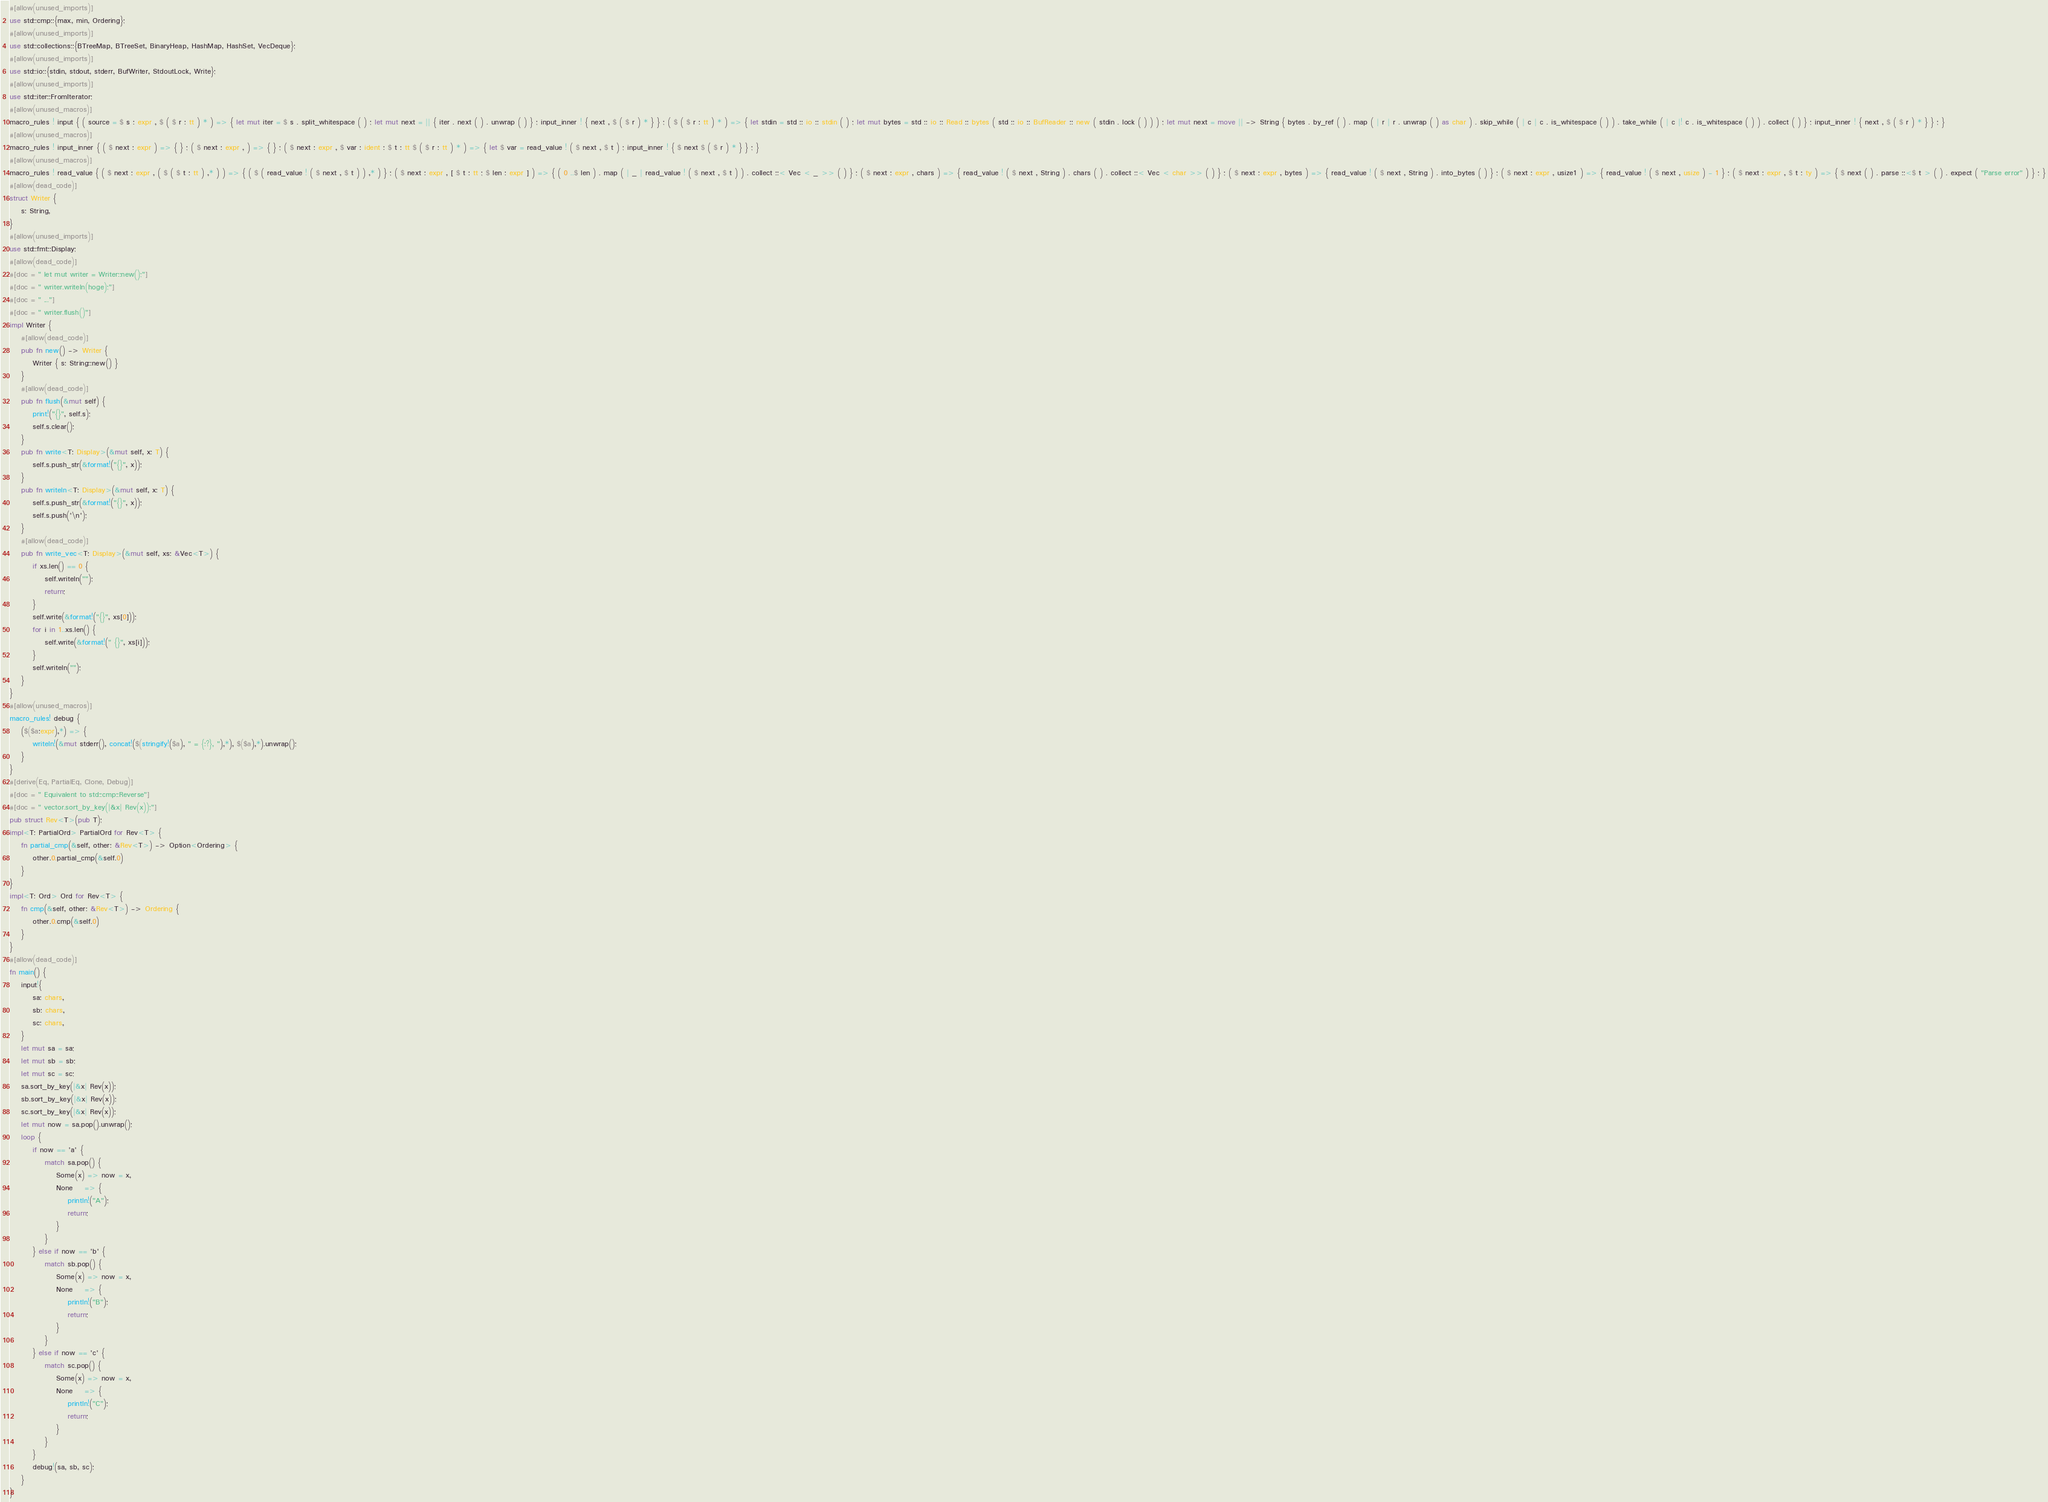<code> <loc_0><loc_0><loc_500><loc_500><_Rust_>#[allow(unused_imports)]
use std::cmp::{max, min, Ordering};
#[allow(unused_imports)]
use std::collections::{BTreeMap, BTreeSet, BinaryHeap, HashMap, HashSet, VecDeque};
#[allow(unused_imports)]
use std::io::{stdin, stdout, stderr, BufWriter, StdoutLock, Write};
#[allow(unused_imports)]
use std::iter::FromIterator;
#[allow(unused_macros)]
macro_rules ! input { ( source = $ s : expr , $ ( $ r : tt ) * ) => { let mut iter = $ s . split_whitespace ( ) ; let mut next = || { iter . next ( ) . unwrap ( ) } ; input_inner ! { next , $ ( $ r ) * } } ; ( $ ( $ r : tt ) * ) => { let stdin = std :: io :: stdin ( ) ; let mut bytes = std :: io :: Read :: bytes ( std :: io :: BufReader :: new ( stdin . lock ( ) ) ) ; let mut next = move || -> String { bytes . by_ref ( ) . map ( | r | r . unwrap ( ) as char ) . skip_while ( | c | c . is_whitespace ( ) ) . take_while ( | c |! c . is_whitespace ( ) ) . collect ( ) } ; input_inner ! { next , $ ( $ r ) * } } ; }
#[allow(unused_macros)]
macro_rules ! input_inner { ( $ next : expr ) => { } ; ( $ next : expr , ) => { } ; ( $ next : expr , $ var : ident : $ t : tt $ ( $ r : tt ) * ) => { let $ var = read_value ! ( $ next , $ t ) ; input_inner ! { $ next $ ( $ r ) * } } ; }
#[allow(unused_macros)]
macro_rules ! read_value { ( $ next : expr , ( $ ( $ t : tt ) ,* ) ) => { ( $ ( read_value ! ( $ next , $ t ) ) ,* ) } ; ( $ next : expr , [ $ t : tt ; $ len : expr ] ) => { ( 0 ..$ len ) . map ( | _ | read_value ! ( $ next , $ t ) ) . collect ::< Vec < _ >> ( ) } ; ( $ next : expr , chars ) => { read_value ! ( $ next , String ) . chars ( ) . collect ::< Vec < char >> ( ) } ; ( $ next : expr , bytes ) => { read_value ! ( $ next , String ) . into_bytes ( ) } ; ( $ next : expr , usize1 ) => { read_value ! ( $ next , usize ) - 1 } ; ( $ next : expr , $ t : ty ) => { $ next ( ) . parse ::<$ t > ( ) . expect ( "Parse error" ) } ; }
#[allow(dead_code)]
struct Writer {
    s: String,
}
#[allow(unused_imports)]
use std::fmt::Display;
#[allow(dead_code)]
#[doc = " let mut writer = Writer::new();"]
#[doc = " writer.writeln(hoge);"]
#[doc = " ..."]
#[doc = " writer.flush()"]
impl Writer {
    #[allow(dead_code)]
    pub fn new() -> Writer {
        Writer { s: String::new() }
    }
    #[allow(dead_code)]
    pub fn flush(&mut self) {
        print!("{}", self.s);
        self.s.clear();
    }
    pub fn write<T: Display>(&mut self, x: T) {
        self.s.push_str(&format!("{}", x));
    }
    pub fn writeln<T: Display>(&mut self, x: T) {
        self.s.push_str(&format!("{}", x));
        self.s.push('\n');
    }
    #[allow(dead_code)]
    pub fn write_vec<T: Display>(&mut self, xs: &Vec<T>) {
        if xs.len() == 0 {
            self.writeln("");
            return;
        }
        self.write(&format!("{}", xs[0]));
        for i in 1..xs.len() {
            self.write(&format!(" {}", xs[i]));
        }
        self.writeln("");
    }
}
#[allow(unused_macros)]
macro_rules! debug {
    ($($a:expr),*) => {
        writeln!(&mut stderr(), concat!($(stringify!($a), " = {:?}, "),*), $($a),*).unwrap();
    }
}
#[derive(Eq, PartialEq, Clone, Debug)]
#[doc = " Equivalent to std::cmp::Reverse"]
#[doc = " vector.sort_by_key(|&x| Rev(x));"]
pub struct Rev<T>(pub T);
impl<T: PartialOrd> PartialOrd for Rev<T> {
    fn partial_cmp(&self, other: &Rev<T>) -> Option<Ordering> {
        other.0.partial_cmp(&self.0)
    }
}
impl<T: Ord> Ord for Rev<T> {
    fn cmp(&self, other: &Rev<T>) -> Ordering {
        other.0.cmp(&self.0)
    }
}
#[allow(dead_code)]
fn main() {
    input!{
        sa: chars,
        sb: chars,
        sc: chars,
    }
    let mut sa = sa;
    let mut sb = sb;
    let mut sc = sc;
    sa.sort_by_key(|&x| Rev(x));
    sb.sort_by_key(|&x| Rev(x));
    sc.sort_by_key(|&x| Rev(x));
    let mut now = sa.pop().unwrap();
    loop {
        if now == 'a' {
            match sa.pop() {
                Some(x) => now = x,
                None    => {
                    println!("A");
                    return;
                }
            }
        } else if now == 'b' {
            match sb.pop() {
                Some(x) => now = x,
                None    => {
                    println!("B");
                    return;
                }
            }
        } else if now == 'c' {
            match sc.pop() {
                Some(x) => now = x,
                None    => {
                    println!("C");
                    return;
                }
            }
        }
        debug!(sa, sb, sc);
    }
}</code> 